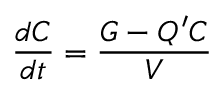<formula> <loc_0><loc_0><loc_500><loc_500>{ \frac { d C } { d t } } = { \frac { G - Q ^ { \prime } C } { V } }</formula> 